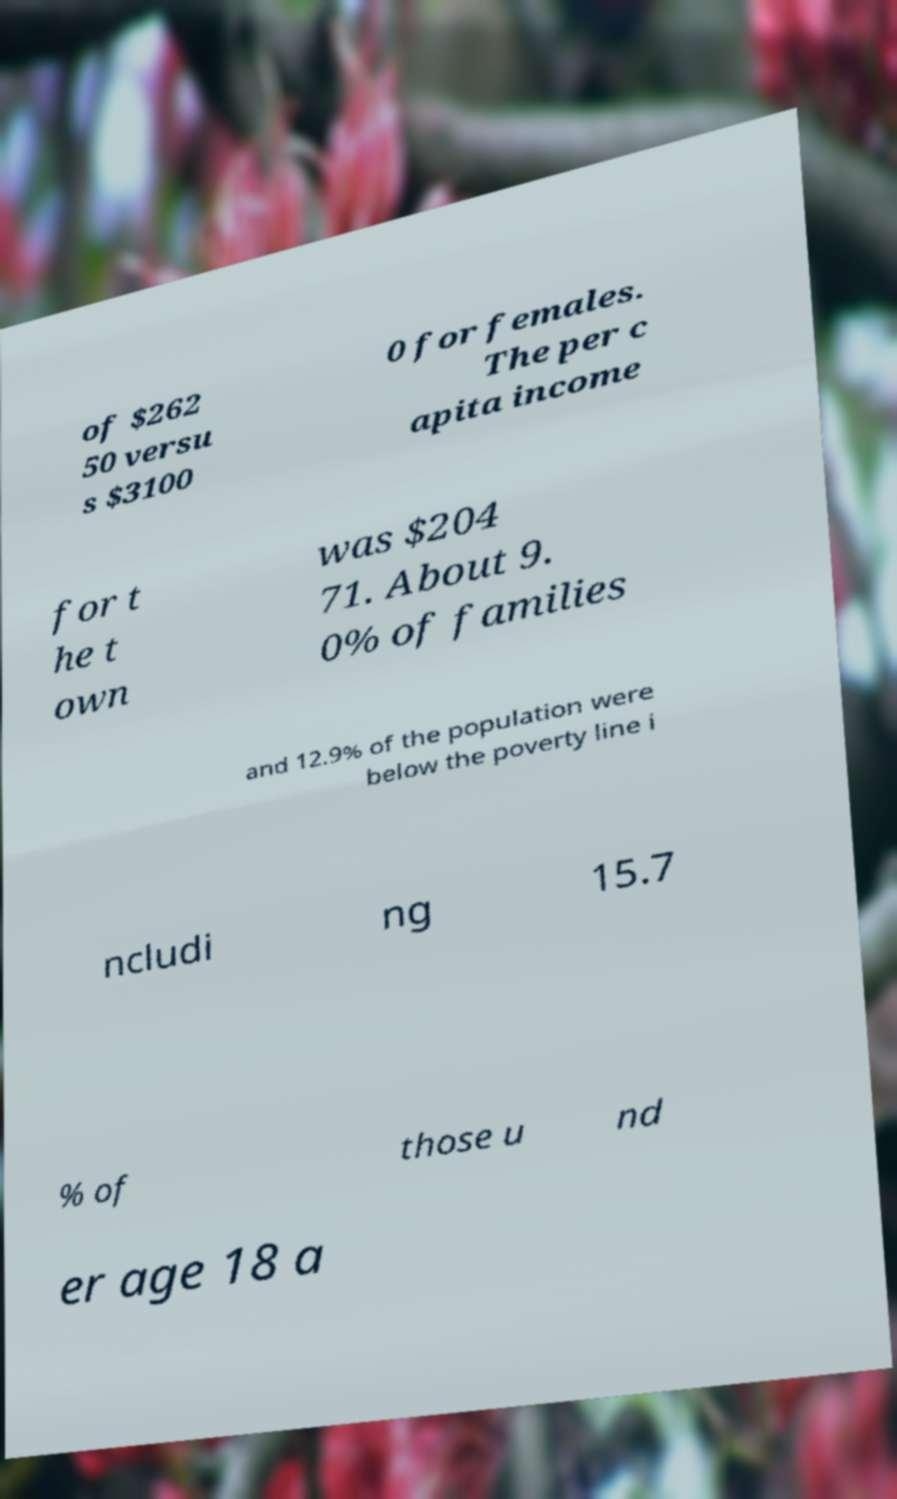What messages or text are displayed in this image? I need them in a readable, typed format. of $262 50 versu s $3100 0 for females. The per c apita income for t he t own was $204 71. About 9. 0% of families and 12.9% of the population were below the poverty line i ncludi ng 15.7 % of those u nd er age 18 a 